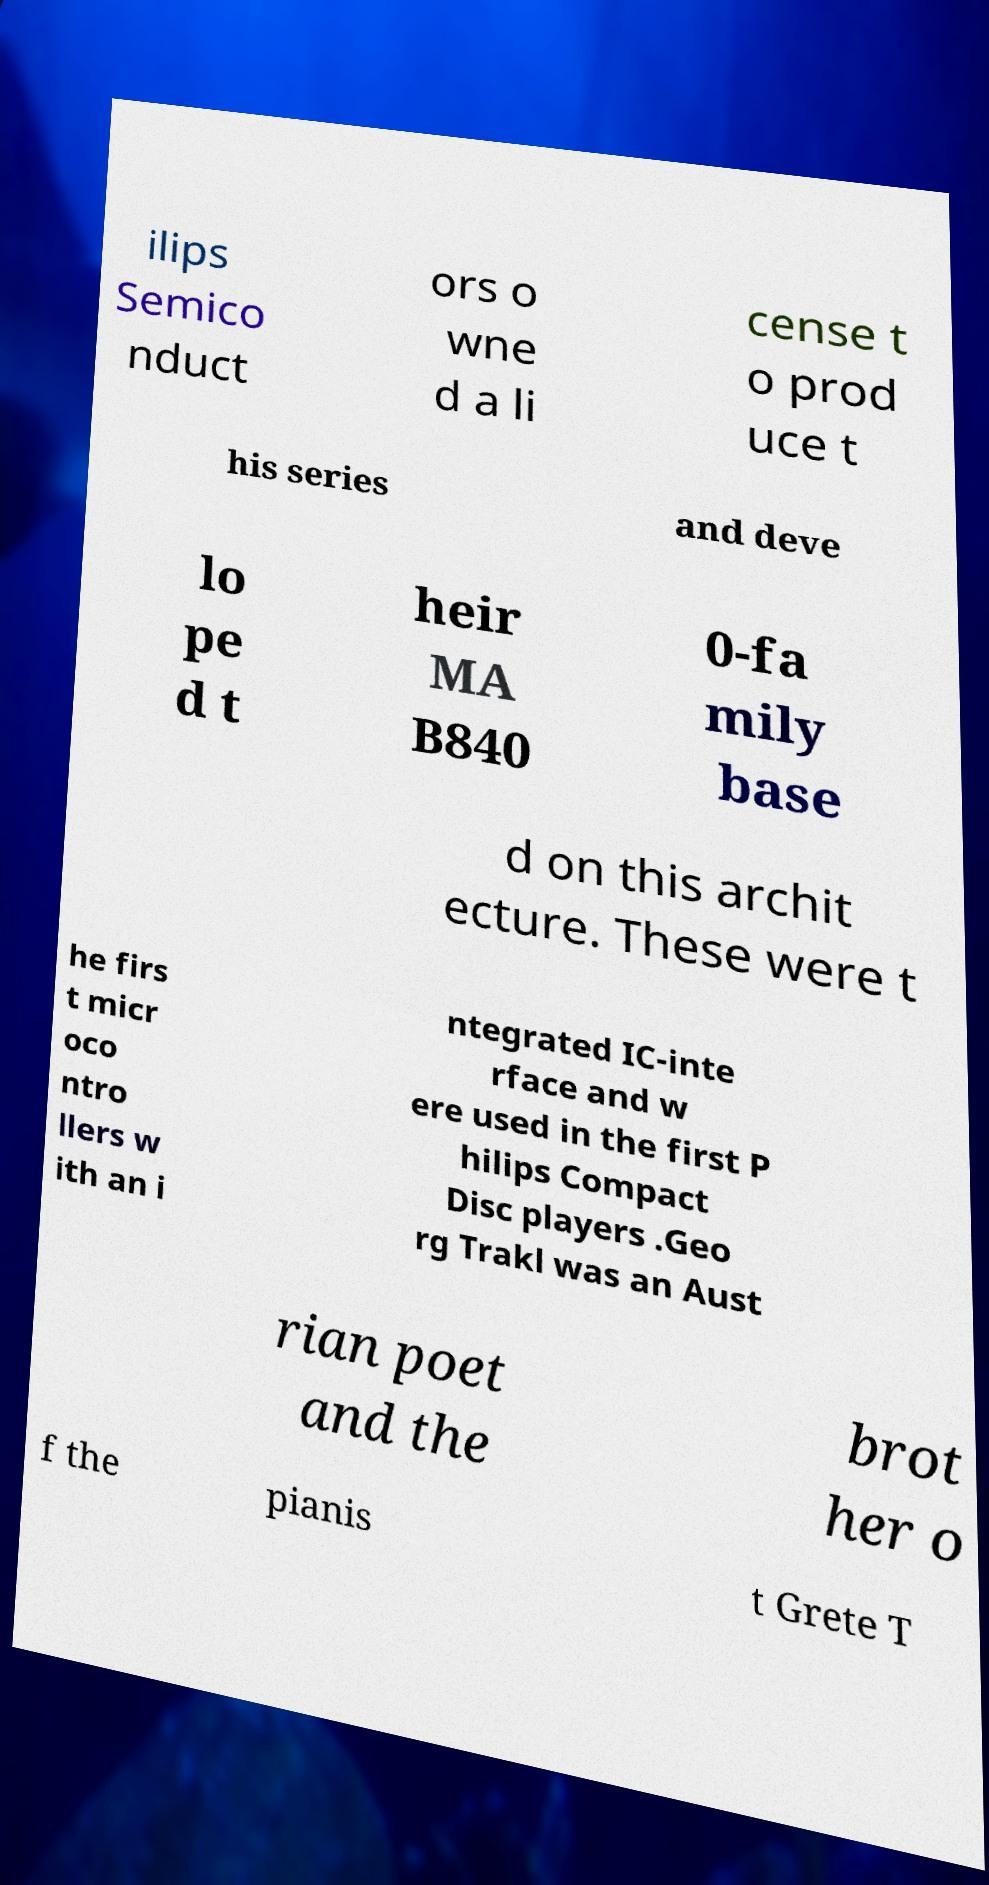I need the written content from this picture converted into text. Can you do that? ilips Semico nduct ors o wne d a li cense t o prod uce t his series and deve lo pe d t heir MA B840 0-fa mily base d on this archit ecture. These were t he firs t micr oco ntro llers w ith an i ntegrated IC-inte rface and w ere used in the first P hilips Compact Disc players .Geo rg Trakl was an Aust rian poet and the brot her o f the pianis t Grete T 